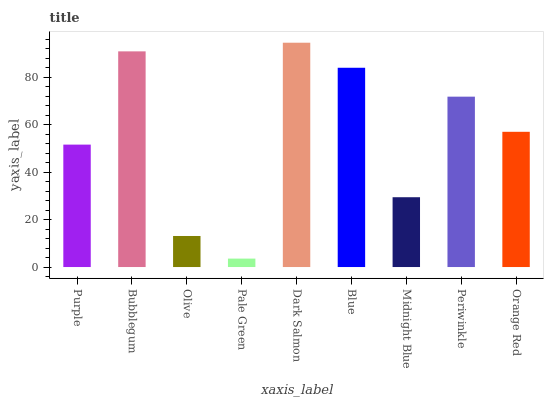Is Pale Green the minimum?
Answer yes or no. Yes. Is Dark Salmon the maximum?
Answer yes or no. Yes. Is Bubblegum the minimum?
Answer yes or no. No. Is Bubblegum the maximum?
Answer yes or no. No. Is Bubblegum greater than Purple?
Answer yes or no. Yes. Is Purple less than Bubblegum?
Answer yes or no. Yes. Is Purple greater than Bubblegum?
Answer yes or no. No. Is Bubblegum less than Purple?
Answer yes or no. No. Is Orange Red the high median?
Answer yes or no. Yes. Is Orange Red the low median?
Answer yes or no. Yes. Is Dark Salmon the high median?
Answer yes or no. No. Is Midnight Blue the low median?
Answer yes or no. No. 